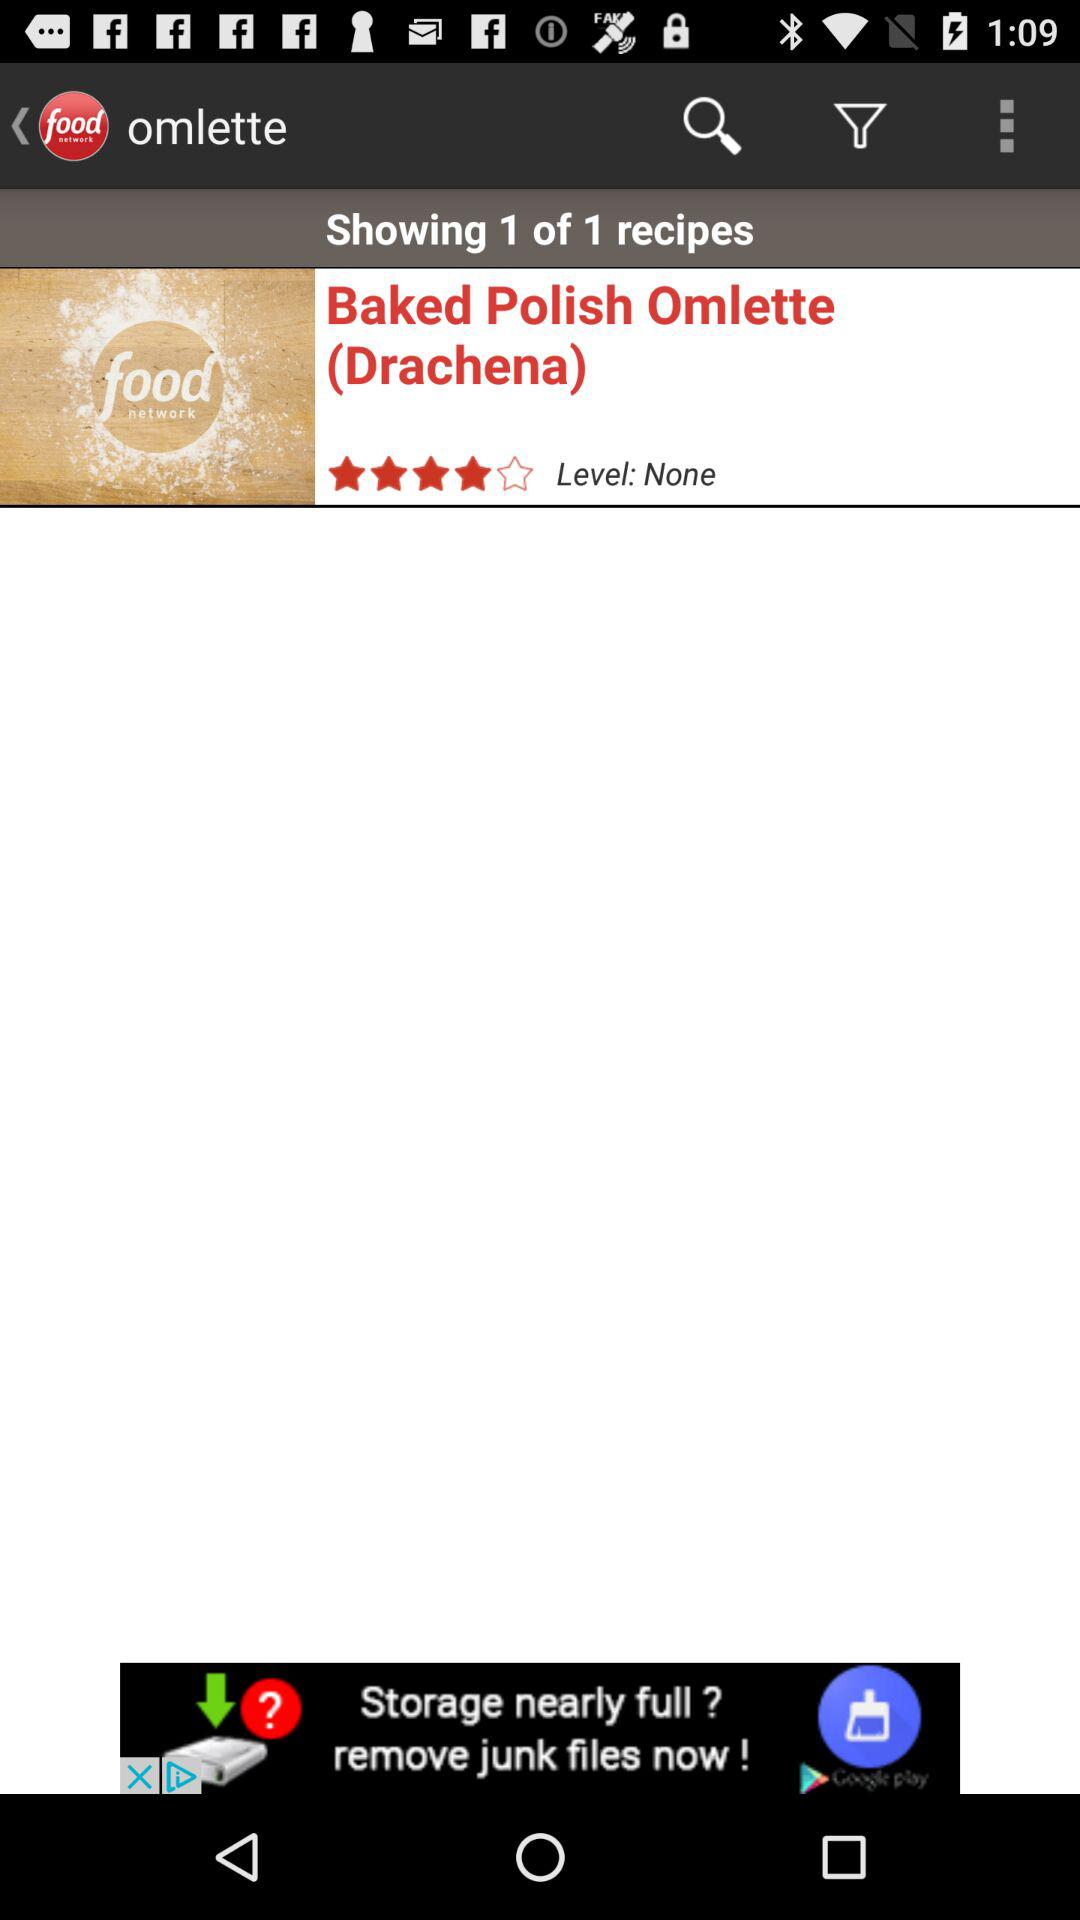What is the name of the recipe shown for Omlette? The name of the recipe is "Baked Polish Omlette (Drachena)". 